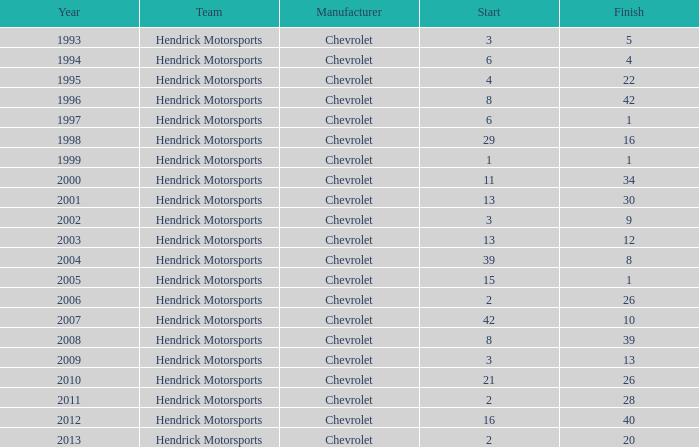What is the number of finishes having a start of 15? 1.0. 